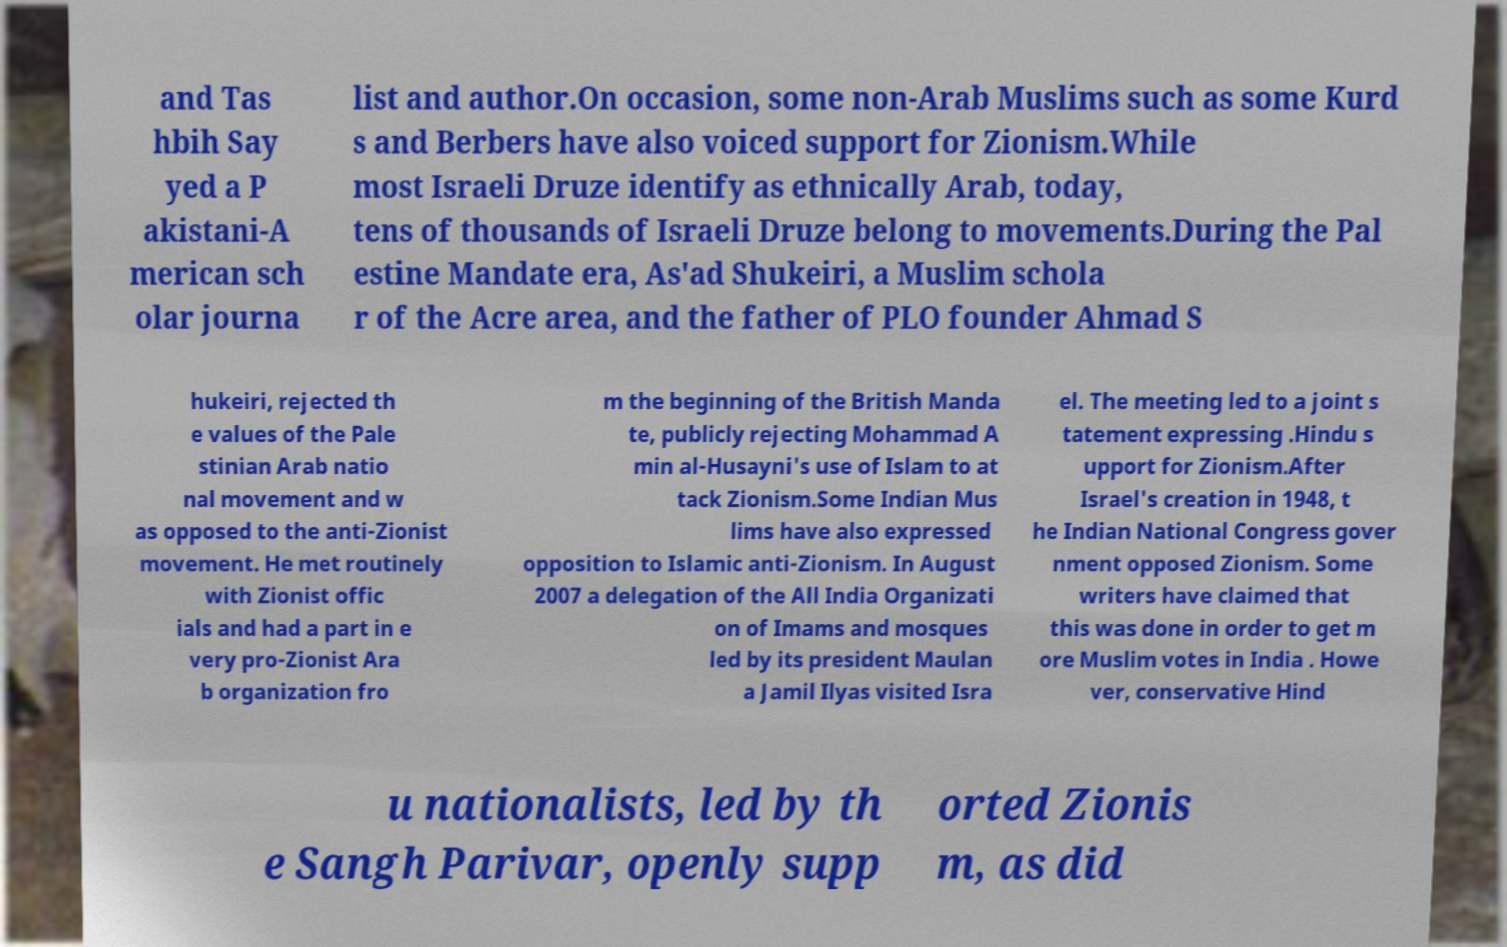What messages or text are displayed in this image? I need them in a readable, typed format. and Tas hbih Say yed a P akistani-A merican sch olar journa list and author.On occasion, some non-Arab Muslims such as some Kurd s and Berbers have also voiced support for Zionism.While most Israeli Druze identify as ethnically Arab, today, tens of thousands of Israeli Druze belong to movements.During the Pal estine Mandate era, As'ad Shukeiri, a Muslim schola r of the Acre area, and the father of PLO founder Ahmad S hukeiri, rejected th e values of the Pale stinian Arab natio nal movement and w as opposed to the anti-Zionist movement. He met routinely with Zionist offic ials and had a part in e very pro-Zionist Ara b organization fro m the beginning of the British Manda te, publicly rejecting Mohammad A min al-Husayni's use of Islam to at tack Zionism.Some Indian Mus lims have also expressed opposition to Islamic anti-Zionism. In August 2007 a delegation of the All India Organizati on of Imams and mosques led by its president Maulan a Jamil Ilyas visited Isra el. The meeting led to a joint s tatement expressing .Hindu s upport for Zionism.After Israel's creation in 1948, t he Indian National Congress gover nment opposed Zionism. Some writers have claimed that this was done in order to get m ore Muslim votes in India . Howe ver, conservative Hind u nationalists, led by th e Sangh Parivar, openly supp orted Zionis m, as did 